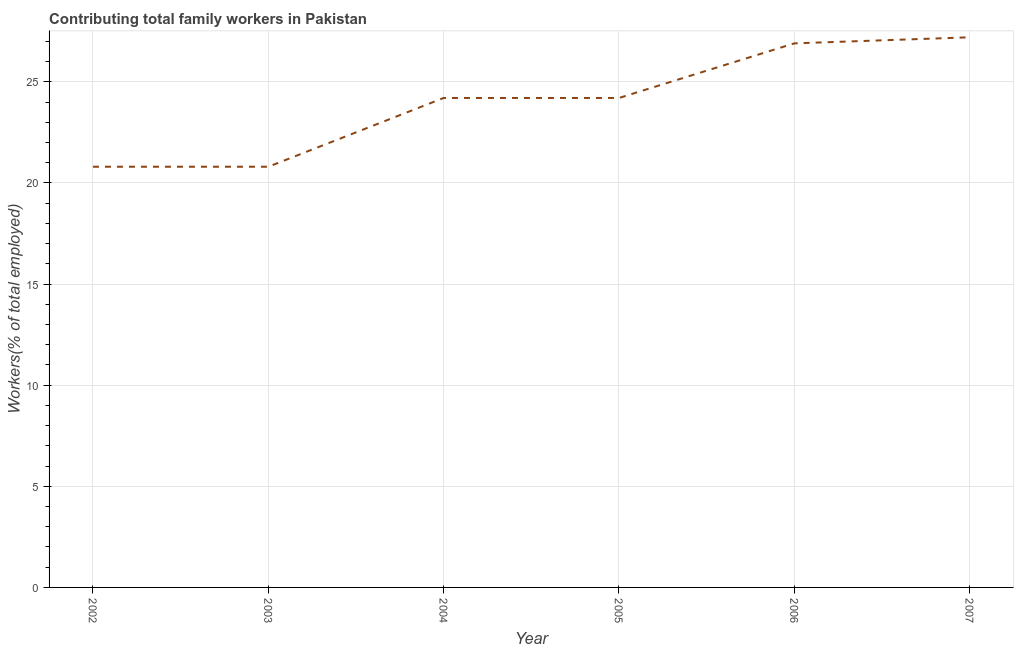What is the contributing family workers in 2005?
Make the answer very short. 24.2. Across all years, what is the maximum contributing family workers?
Keep it short and to the point. 27.2. Across all years, what is the minimum contributing family workers?
Offer a terse response. 20.8. In which year was the contributing family workers minimum?
Offer a very short reply. 2002. What is the sum of the contributing family workers?
Make the answer very short. 144.1. What is the difference between the contributing family workers in 2003 and 2007?
Provide a succinct answer. -6.4. What is the average contributing family workers per year?
Provide a succinct answer. 24.02. What is the median contributing family workers?
Your response must be concise. 24.2. In how many years, is the contributing family workers greater than 10 %?
Provide a succinct answer. 6. Do a majority of the years between 2006 and 2003 (inclusive) have contributing family workers greater than 22 %?
Give a very brief answer. Yes. What is the difference between the highest and the second highest contributing family workers?
Keep it short and to the point. 0.3. Is the sum of the contributing family workers in 2006 and 2007 greater than the maximum contributing family workers across all years?
Provide a succinct answer. Yes. What is the difference between the highest and the lowest contributing family workers?
Provide a succinct answer. 6.4. In how many years, is the contributing family workers greater than the average contributing family workers taken over all years?
Provide a succinct answer. 4. Does the contributing family workers monotonically increase over the years?
Keep it short and to the point. No. How many years are there in the graph?
Keep it short and to the point. 6. What is the difference between two consecutive major ticks on the Y-axis?
Offer a terse response. 5. Are the values on the major ticks of Y-axis written in scientific E-notation?
Offer a terse response. No. Does the graph contain grids?
Ensure brevity in your answer.  Yes. What is the title of the graph?
Offer a very short reply. Contributing total family workers in Pakistan. What is the label or title of the X-axis?
Ensure brevity in your answer.  Year. What is the label or title of the Y-axis?
Provide a short and direct response. Workers(% of total employed). What is the Workers(% of total employed) of 2002?
Ensure brevity in your answer.  20.8. What is the Workers(% of total employed) of 2003?
Give a very brief answer. 20.8. What is the Workers(% of total employed) in 2004?
Provide a short and direct response. 24.2. What is the Workers(% of total employed) in 2005?
Provide a succinct answer. 24.2. What is the Workers(% of total employed) of 2006?
Give a very brief answer. 26.9. What is the Workers(% of total employed) in 2007?
Offer a terse response. 27.2. What is the difference between the Workers(% of total employed) in 2002 and 2003?
Give a very brief answer. 0. What is the difference between the Workers(% of total employed) in 2002 and 2005?
Ensure brevity in your answer.  -3.4. What is the difference between the Workers(% of total employed) in 2003 and 2007?
Keep it short and to the point. -6.4. What is the difference between the Workers(% of total employed) in 2004 and 2005?
Make the answer very short. 0. What is the difference between the Workers(% of total employed) in 2004 and 2007?
Provide a succinct answer. -3. What is the difference between the Workers(% of total employed) in 2005 and 2007?
Ensure brevity in your answer.  -3. What is the ratio of the Workers(% of total employed) in 2002 to that in 2004?
Your answer should be very brief. 0.86. What is the ratio of the Workers(% of total employed) in 2002 to that in 2005?
Your response must be concise. 0.86. What is the ratio of the Workers(% of total employed) in 2002 to that in 2006?
Your response must be concise. 0.77. What is the ratio of the Workers(% of total employed) in 2002 to that in 2007?
Your answer should be very brief. 0.77. What is the ratio of the Workers(% of total employed) in 2003 to that in 2004?
Keep it short and to the point. 0.86. What is the ratio of the Workers(% of total employed) in 2003 to that in 2005?
Your answer should be very brief. 0.86. What is the ratio of the Workers(% of total employed) in 2003 to that in 2006?
Your answer should be compact. 0.77. What is the ratio of the Workers(% of total employed) in 2003 to that in 2007?
Your response must be concise. 0.77. What is the ratio of the Workers(% of total employed) in 2004 to that in 2005?
Give a very brief answer. 1. What is the ratio of the Workers(% of total employed) in 2004 to that in 2007?
Offer a very short reply. 0.89. What is the ratio of the Workers(% of total employed) in 2005 to that in 2007?
Make the answer very short. 0.89. What is the ratio of the Workers(% of total employed) in 2006 to that in 2007?
Your answer should be very brief. 0.99. 